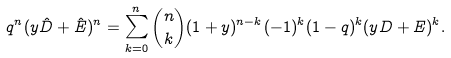<formula> <loc_0><loc_0><loc_500><loc_500>q ^ { n } ( y \hat { D } + \hat { E } ) ^ { n } = \sum _ { k = 0 } ^ { n } \binom { n } { k } ( 1 + y ) ^ { n - k } ( - 1 ) ^ { k } ( 1 - q ) ^ { k } ( y D + E ) ^ { k } .</formula> 